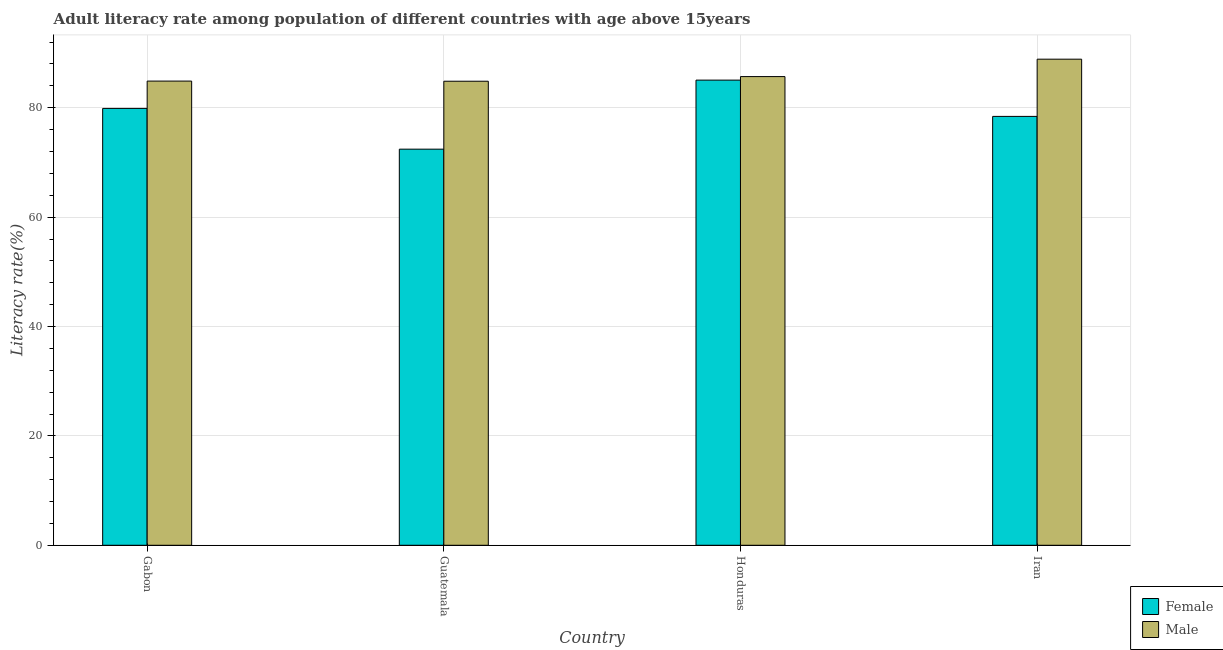What is the label of the 2nd group of bars from the left?
Ensure brevity in your answer.  Guatemala. What is the male adult literacy rate in Guatemala?
Your answer should be compact. 84.85. Across all countries, what is the maximum male adult literacy rate?
Make the answer very short. 88.88. Across all countries, what is the minimum male adult literacy rate?
Make the answer very short. 84.85. In which country was the male adult literacy rate maximum?
Your answer should be very brief. Iran. In which country was the male adult literacy rate minimum?
Offer a terse response. Guatemala. What is the total male adult literacy rate in the graph?
Ensure brevity in your answer.  344.3. What is the difference between the male adult literacy rate in Gabon and that in Guatemala?
Keep it short and to the point. 0.02. What is the difference between the female adult literacy rate in Iran and the male adult literacy rate in Honduras?
Ensure brevity in your answer.  -7.28. What is the average male adult literacy rate per country?
Provide a succinct answer. 86.07. What is the difference between the male adult literacy rate and female adult literacy rate in Gabon?
Offer a terse response. 4.99. What is the ratio of the female adult literacy rate in Guatemala to that in Honduras?
Offer a very short reply. 0.85. Is the male adult literacy rate in Gabon less than that in Honduras?
Your answer should be compact. Yes. What is the difference between the highest and the second highest female adult literacy rate?
Keep it short and to the point. 5.17. What is the difference between the highest and the lowest female adult literacy rate?
Your answer should be compact. 12.62. How many bars are there?
Your response must be concise. 8. Are all the bars in the graph horizontal?
Give a very brief answer. No. Are the values on the major ticks of Y-axis written in scientific E-notation?
Give a very brief answer. No. Does the graph contain any zero values?
Your answer should be compact. No. Does the graph contain grids?
Your answer should be very brief. Yes. How are the legend labels stacked?
Give a very brief answer. Vertical. What is the title of the graph?
Your answer should be very brief. Adult literacy rate among population of different countries with age above 15years. Does "Techinal cooperation" appear as one of the legend labels in the graph?
Provide a short and direct response. No. What is the label or title of the X-axis?
Provide a short and direct response. Country. What is the label or title of the Y-axis?
Offer a very short reply. Literacy rate(%). What is the Literacy rate(%) in Female in Gabon?
Your answer should be compact. 79.88. What is the Literacy rate(%) of Male in Gabon?
Provide a succinct answer. 84.87. What is the Literacy rate(%) in Female in Guatemala?
Ensure brevity in your answer.  72.43. What is the Literacy rate(%) of Male in Guatemala?
Ensure brevity in your answer.  84.85. What is the Literacy rate(%) in Female in Honduras?
Offer a terse response. 85.05. What is the Literacy rate(%) in Male in Honduras?
Ensure brevity in your answer.  85.7. What is the Literacy rate(%) in Female in Iran?
Ensure brevity in your answer.  78.42. What is the Literacy rate(%) of Male in Iran?
Ensure brevity in your answer.  88.88. Across all countries, what is the maximum Literacy rate(%) of Female?
Your answer should be very brief. 85.05. Across all countries, what is the maximum Literacy rate(%) in Male?
Provide a short and direct response. 88.88. Across all countries, what is the minimum Literacy rate(%) in Female?
Give a very brief answer. 72.43. Across all countries, what is the minimum Literacy rate(%) of Male?
Your answer should be compact. 84.85. What is the total Literacy rate(%) of Female in the graph?
Provide a short and direct response. 315.77. What is the total Literacy rate(%) of Male in the graph?
Give a very brief answer. 344.3. What is the difference between the Literacy rate(%) in Female in Gabon and that in Guatemala?
Give a very brief answer. 7.45. What is the difference between the Literacy rate(%) of Male in Gabon and that in Guatemala?
Offer a terse response. 0.02. What is the difference between the Literacy rate(%) of Female in Gabon and that in Honduras?
Provide a short and direct response. -5.17. What is the difference between the Literacy rate(%) in Male in Gabon and that in Honduras?
Keep it short and to the point. -0.82. What is the difference between the Literacy rate(%) in Female in Gabon and that in Iran?
Offer a terse response. 1.46. What is the difference between the Literacy rate(%) in Male in Gabon and that in Iran?
Give a very brief answer. -4.01. What is the difference between the Literacy rate(%) of Female in Guatemala and that in Honduras?
Make the answer very short. -12.62. What is the difference between the Literacy rate(%) in Male in Guatemala and that in Honduras?
Give a very brief answer. -0.85. What is the difference between the Literacy rate(%) of Female in Guatemala and that in Iran?
Provide a short and direct response. -5.99. What is the difference between the Literacy rate(%) in Male in Guatemala and that in Iran?
Provide a short and direct response. -4.03. What is the difference between the Literacy rate(%) of Female in Honduras and that in Iran?
Ensure brevity in your answer.  6.64. What is the difference between the Literacy rate(%) in Male in Honduras and that in Iran?
Your response must be concise. -3.18. What is the difference between the Literacy rate(%) in Female in Gabon and the Literacy rate(%) in Male in Guatemala?
Offer a very short reply. -4.97. What is the difference between the Literacy rate(%) of Female in Gabon and the Literacy rate(%) of Male in Honduras?
Provide a short and direct response. -5.82. What is the difference between the Literacy rate(%) of Female in Gabon and the Literacy rate(%) of Male in Iran?
Ensure brevity in your answer.  -9. What is the difference between the Literacy rate(%) of Female in Guatemala and the Literacy rate(%) of Male in Honduras?
Ensure brevity in your answer.  -13.27. What is the difference between the Literacy rate(%) in Female in Guatemala and the Literacy rate(%) in Male in Iran?
Your response must be concise. -16.45. What is the difference between the Literacy rate(%) of Female in Honduras and the Literacy rate(%) of Male in Iran?
Your response must be concise. -3.83. What is the average Literacy rate(%) in Female per country?
Ensure brevity in your answer.  78.94. What is the average Literacy rate(%) of Male per country?
Keep it short and to the point. 86.07. What is the difference between the Literacy rate(%) in Female and Literacy rate(%) in Male in Gabon?
Make the answer very short. -4.99. What is the difference between the Literacy rate(%) of Female and Literacy rate(%) of Male in Guatemala?
Your answer should be very brief. -12.42. What is the difference between the Literacy rate(%) of Female and Literacy rate(%) of Male in Honduras?
Keep it short and to the point. -0.64. What is the difference between the Literacy rate(%) of Female and Literacy rate(%) of Male in Iran?
Your response must be concise. -10.46. What is the ratio of the Literacy rate(%) of Female in Gabon to that in Guatemala?
Offer a very short reply. 1.1. What is the ratio of the Literacy rate(%) of Male in Gabon to that in Guatemala?
Provide a short and direct response. 1. What is the ratio of the Literacy rate(%) in Female in Gabon to that in Honduras?
Offer a terse response. 0.94. What is the ratio of the Literacy rate(%) of Male in Gabon to that in Honduras?
Your answer should be compact. 0.99. What is the ratio of the Literacy rate(%) in Female in Gabon to that in Iran?
Offer a terse response. 1.02. What is the ratio of the Literacy rate(%) in Male in Gabon to that in Iran?
Your answer should be very brief. 0.95. What is the ratio of the Literacy rate(%) in Female in Guatemala to that in Honduras?
Make the answer very short. 0.85. What is the ratio of the Literacy rate(%) in Male in Guatemala to that in Honduras?
Give a very brief answer. 0.99. What is the ratio of the Literacy rate(%) of Female in Guatemala to that in Iran?
Ensure brevity in your answer.  0.92. What is the ratio of the Literacy rate(%) in Male in Guatemala to that in Iran?
Make the answer very short. 0.95. What is the ratio of the Literacy rate(%) of Female in Honduras to that in Iran?
Provide a succinct answer. 1.08. What is the ratio of the Literacy rate(%) in Male in Honduras to that in Iran?
Offer a very short reply. 0.96. What is the difference between the highest and the second highest Literacy rate(%) in Female?
Make the answer very short. 5.17. What is the difference between the highest and the second highest Literacy rate(%) of Male?
Your answer should be compact. 3.18. What is the difference between the highest and the lowest Literacy rate(%) of Female?
Your answer should be very brief. 12.62. What is the difference between the highest and the lowest Literacy rate(%) of Male?
Give a very brief answer. 4.03. 